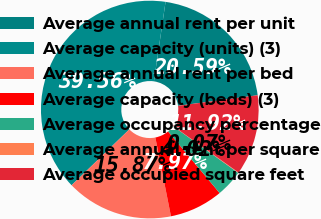Convert chart to OTSL. <chart><loc_0><loc_0><loc_500><loc_500><pie_chart><fcel>Average annual rent per unit<fcel>Average capacity (units) (3)<fcel>Average annual rent per bed<fcel>Average capacity (beds) (3)<fcel>Average occupancy percentage<fcel>Average annual rent per square<fcel>Average occupied square feet<nl><fcel>20.59%<fcel>39.56%<fcel>15.87%<fcel>7.97%<fcel>4.02%<fcel>0.07%<fcel>11.92%<nl></chart> 